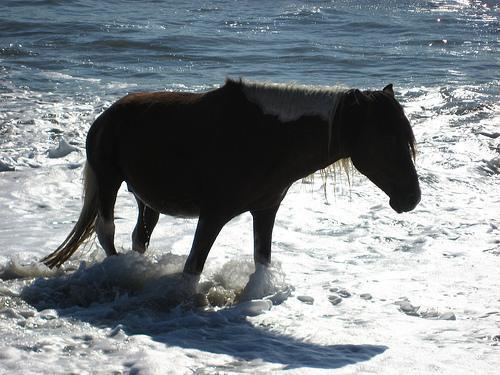How many legs does the horse have?
Give a very brief answer. 4. 